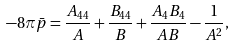<formula> <loc_0><loc_0><loc_500><loc_500>- 8 \pi \bar { p } = \frac { A _ { 4 4 } } { A } + \frac { B _ { 4 4 } } { B } + \frac { A _ { 4 } B _ { 4 } } { A B } - \frac { 1 } { A ^ { 2 } } ,</formula> 